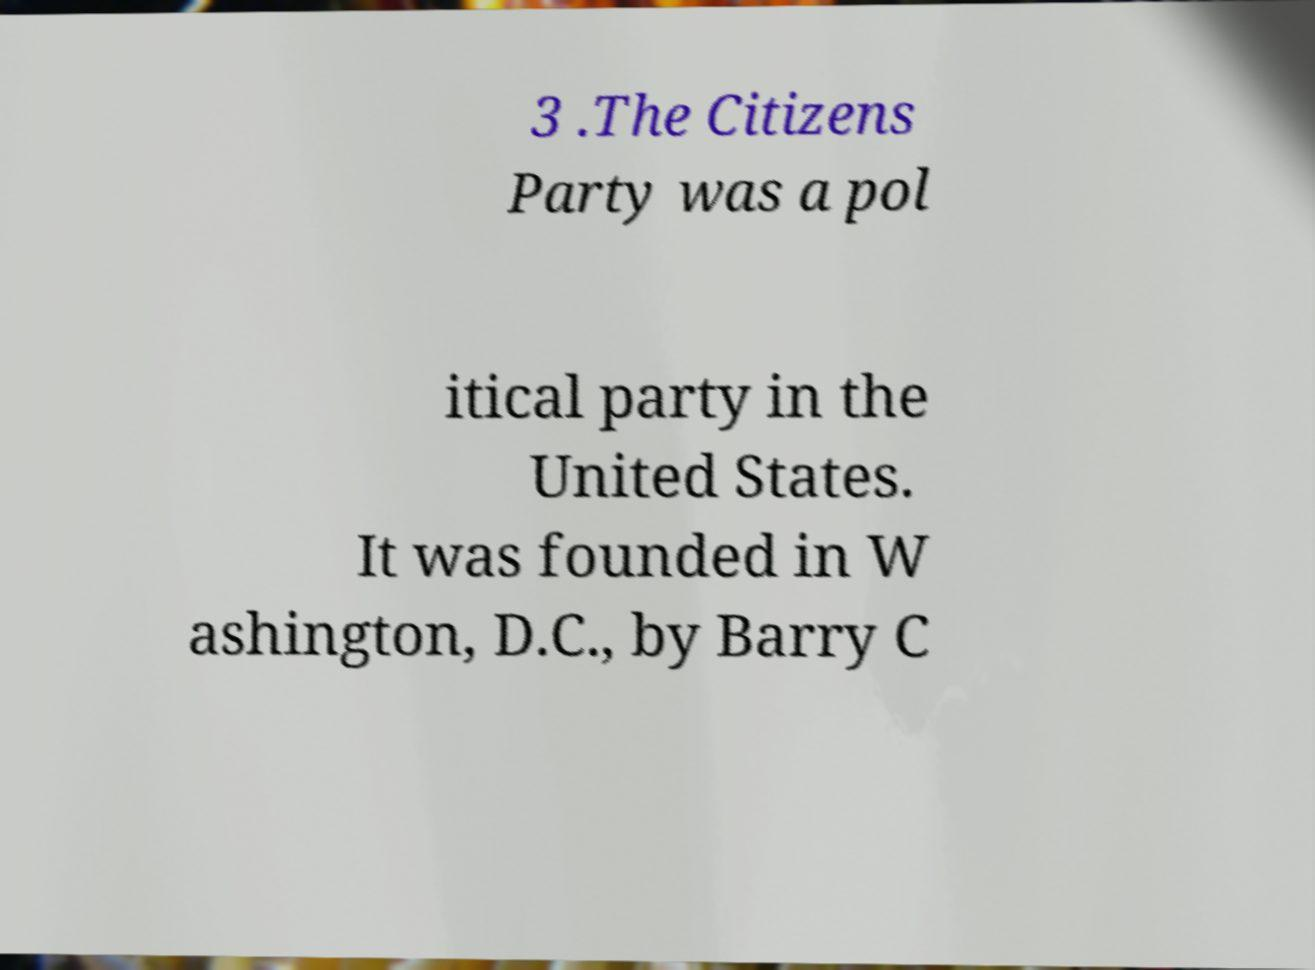I need the written content from this picture converted into text. Can you do that? 3 .The Citizens Party was a pol itical party in the United States. It was founded in W ashington, D.C., by Barry C 